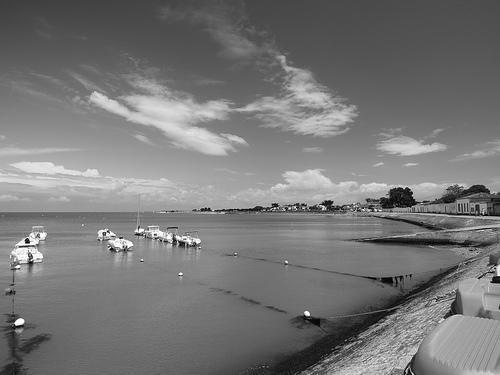How many boats in the photo?
Give a very brief answer. 7. 